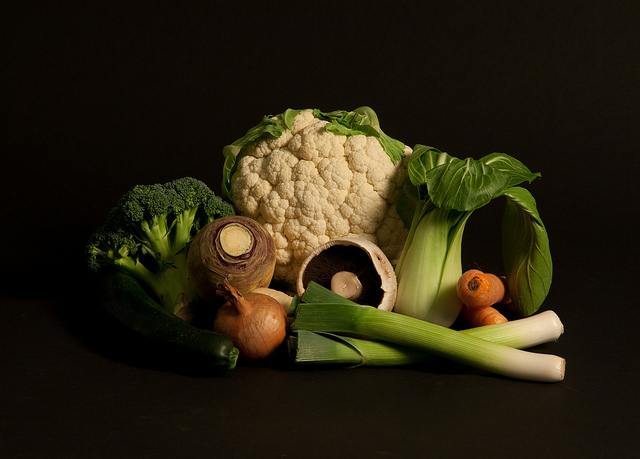Where can these foods be found?
A. fast food
B. bar
C. garden
D. office
Answer with the option's letter from the given choices directly. C. The vegetables shown in the image, which include items like broccoli, cauliflower, leek, onions, and a Portobello mushroom, are typically found in a garden where they are grown. They represent fresh produce that one would harvest from a garden rather than pre-prepared food you'd find at a fast food establishment, a bar, or typical office food. 